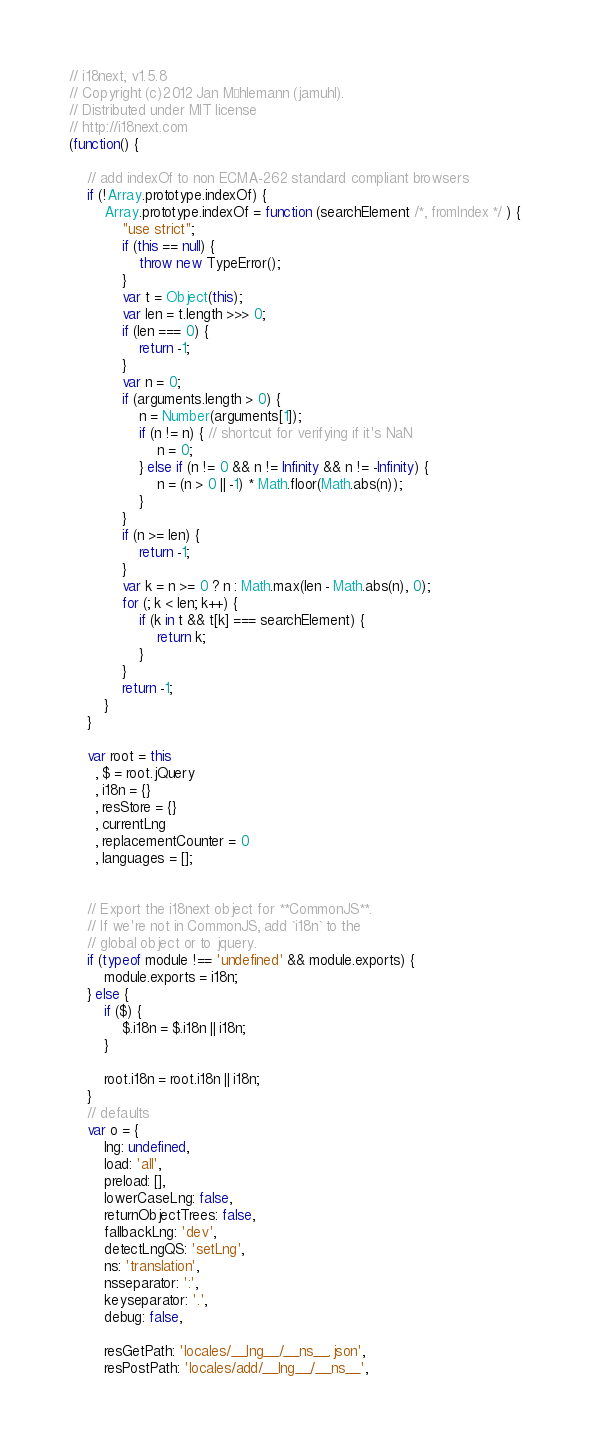<code> <loc_0><loc_0><loc_500><loc_500><_JavaScript_>// i18next, v1.5.8
// Copyright (c)2012 Jan Mühlemann (jamuhl).
// Distributed under MIT license
// http://i18next.com
(function() {

    // add indexOf to non ECMA-262 standard compliant browsers
    if (!Array.prototype.indexOf) {  
        Array.prototype.indexOf = function (searchElement /*, fromIndex */ ) {  
            "use strict";  
            if (this == null) {  
                throw new TypeError();  
            }  
            var t = Object(this);  
            var len = t.length >>> 0;  
            if (len === 0) {  
                return -1;  
            }  
            var n = 0;  
            if (arguments.length > 0) {  
                n = Number(arguments[1]);  
                if (n != n) { // shortcut for verifying if it's NaN  
                    n = 0;  
                } else if (n != 0 && n != Infinity && n != -Infinity) {  
                    n = (n > 0 || -1) * Math.floor(Math.abs(n));  
                }  
            }  
            if (n >= len) {  
                return -1;  
            }  
            var k = n >= 0 ? n : Math.max(len - Math.abs(n), 0);  
            for (; k < len; k++) {  
                if (k in t && t[k] === searchElement) {  
                    return k;  
                }  
            }  
            return -1;  
        }
    } 

    var root = this
      , $ = root.jQuery
      , i18n = {}
      , resStore = {}
      , currentLng
      , replacementCounter = 0
      , languages = [];


    // Export the i18next object for **CommonJS**. 
    // If we're not in CommonJS, add `i18n` to the
    // global object or to jquery.
    if (typeof module !== 'undefined' && module.exports) {
        module.exports = i18n;
    } else {
        if ($) {
            $.i18n = $.i18n || i18n;
        }
        
        root.i18n = root.i18n || i18n;
    }
    // defaults
    var o = {
        lng: undefined,
        load: 'all',
        preload: [],
        lowerCaseLng: false,
        returnObjectTrees: false,
        fallbackLng: 'dev',
        detectLngQS: 'setLng',
        ns: 'translation',
        nsseparator: ':',
        keyseparator: '.',
        debug: false,
        
        resGetPath: 'locales/__lng__/__ns__.json',
        resPostPath: 'locales/add/__lng__/__ns__',</code> 